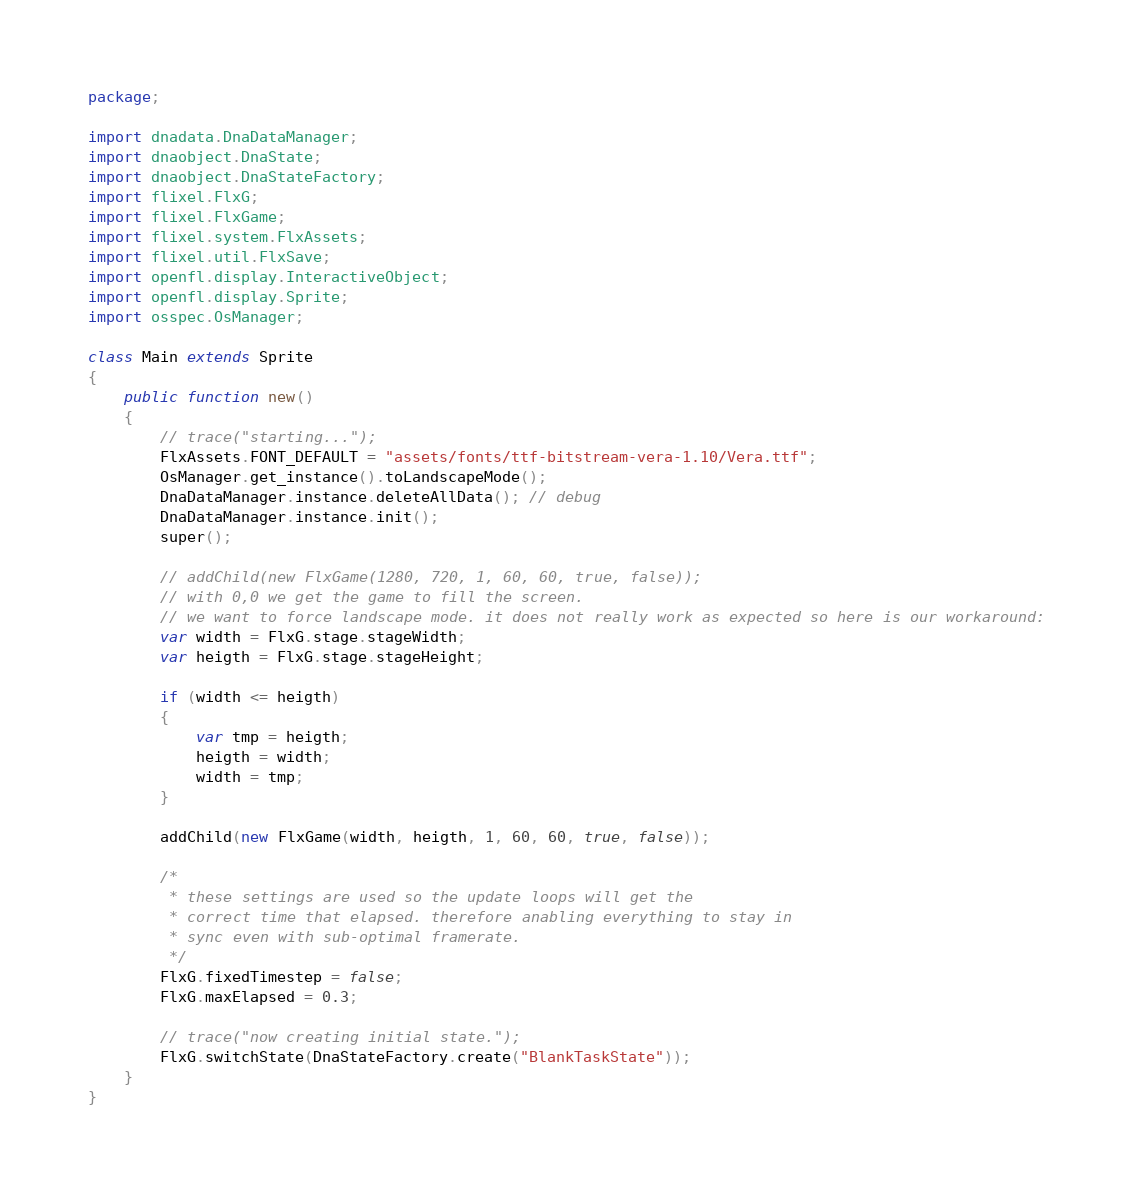<code> <loc_0><loc_0><loc_500><loc_500><_Haxe_>package;

import dnadata.DnaDataManager;
import dnaobject.DnaState;
import dnaobject.DnaStateFactory;
import flixel.FlxG;
import flixel.FlxGame;
import flixel.system.FlxAssets;
import flixel.util.FlxSave;
import openfl.display.InteractiveObject;
import openfl.display.Sprite;
import osspec.OsManager;

class Main extends Sprite
{
	public function new()
	{
		// trace("starting...");
		FlxAssets.FONT_DEFAULT = "assets/fonts/ttf-bitstream-vera-1.10/Vera.ttf";
		OsManager.get_instance().toLandscapeMode();
		DnaDataManager.instance.deleteAllData(); // debug
		DnaDataManager.instance.init();
		super();

		// addChild(new FlxGame(1280, 720, 1, 60, 60, true, false));
		// with 0,0 we get the game to fill the screen.
		// we want to force landscape mode. it does not really work as expected so here is our workaround:
		var width = FlxG.stage.stageWidth;
		var heigth = FlxG.stage.stageHeight;

		if (width <= heigth)
		{
			var tmp = heigth;
			heigth = width;
			width = tmp;
		}

		addChild(new FlxGame(width, heigth, 1, 60, 60, true, false));

		/*
		 * these settings are used so the update loops will get the 
		 * correct time that elapsed. therefore anabling everything to stay in
		 * sync even with sub-optimal framerate.
		 */
		FlxG.fixedTimestep = false;
		FlxG.maxElapsed = 0.3;

		// trace("now creating initial state.");
		FlxG.switchState(DnaStateFactory.create("BlankTaskState"));
	}
}
</code> 